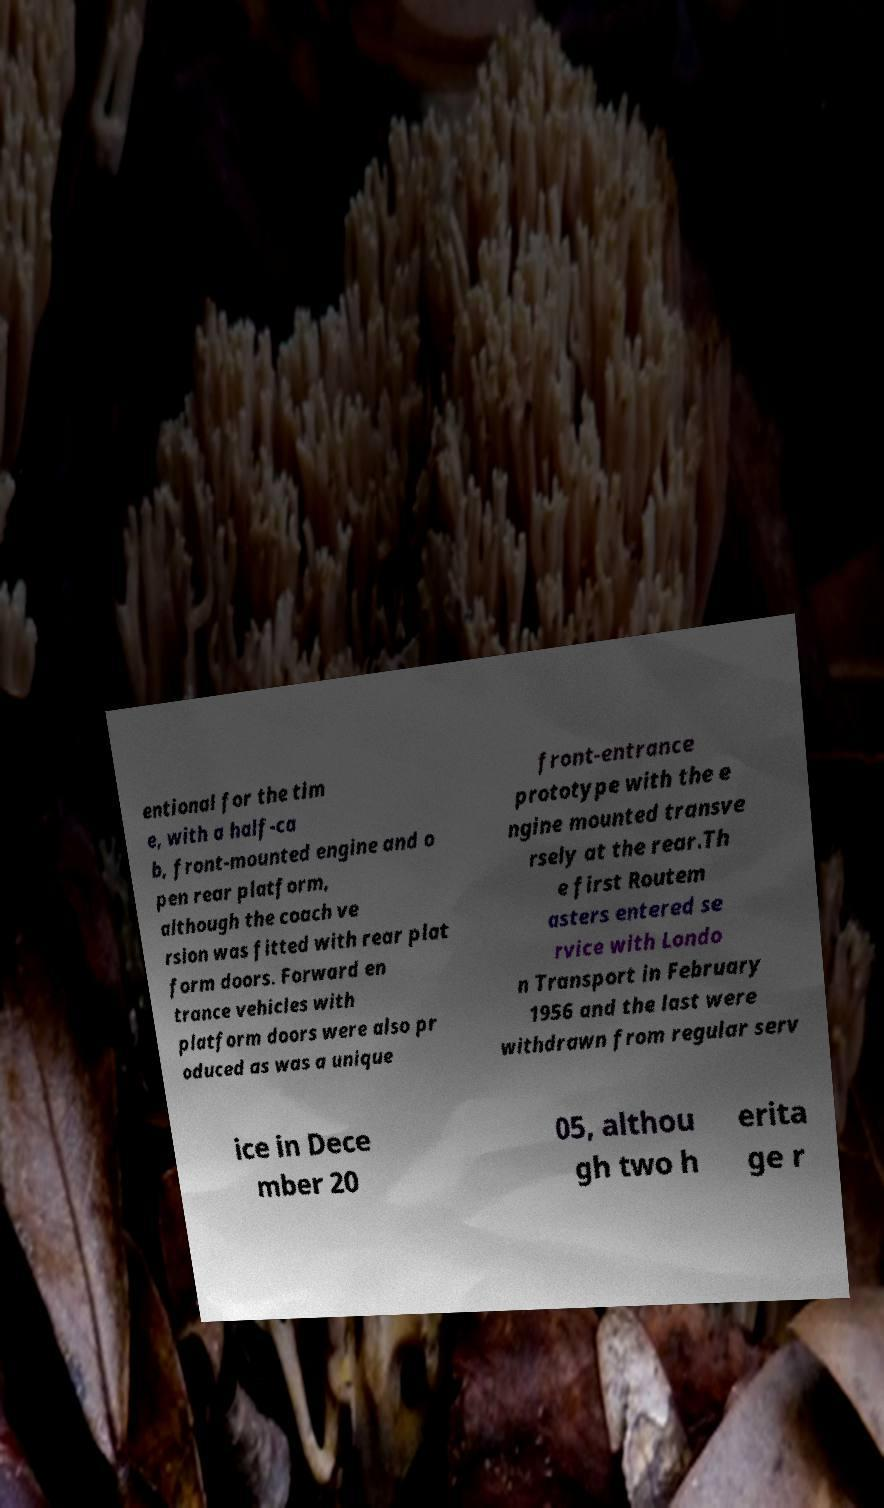Could you assist in decoding the text presented in this image and type it out clearly? entional for the tim e, with a half-ca b, front-mounted engine and o pen rear platform, although the coach ve rsion was fitted with rear plat form doors. Forward en trance vehicles with platform doors were also pr oduced as was a unique front-entrance prototype with the e ngine mounted transve rsely at the rear.Th e first Routem asters entered se rvice with Londo n Transport in February 1956 and the last were withdrawn from regular serv ice in Dece mber 20 05, althou gh two h erita ge r 